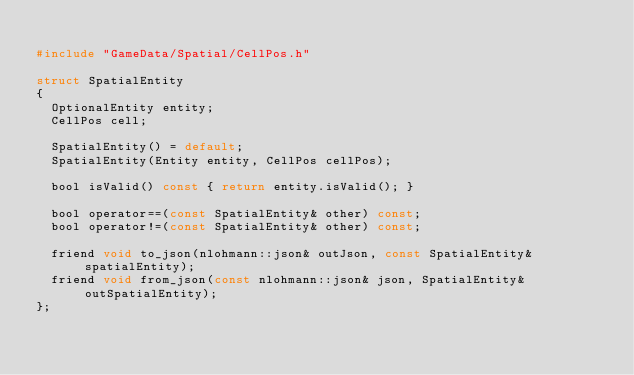<code> <loc_0><loc_0><loc_500><loc_500><_C_>
#include "GameData/Spatial/CellPos.h"

struct SpatialEntity
{
	OptionalEntity entity;
	CellPos cell;

	SpatialEntity() = default;
	SpatialEntity(Entity entity, CellPos cellPos);

	bool isValid() const { return entity.isValid(); }

	bool operator==(const SpatialEntity& other) const;
	bool operator!=(const SpatialEntity& other) const;

	friend void to_json(nlohmann::json& outJson, const SpatialEntity& spatialEntity);
	friend void from_json(const nlohmann::json& json, SpatialEntity& outSpatialEntity);
};
</code> 